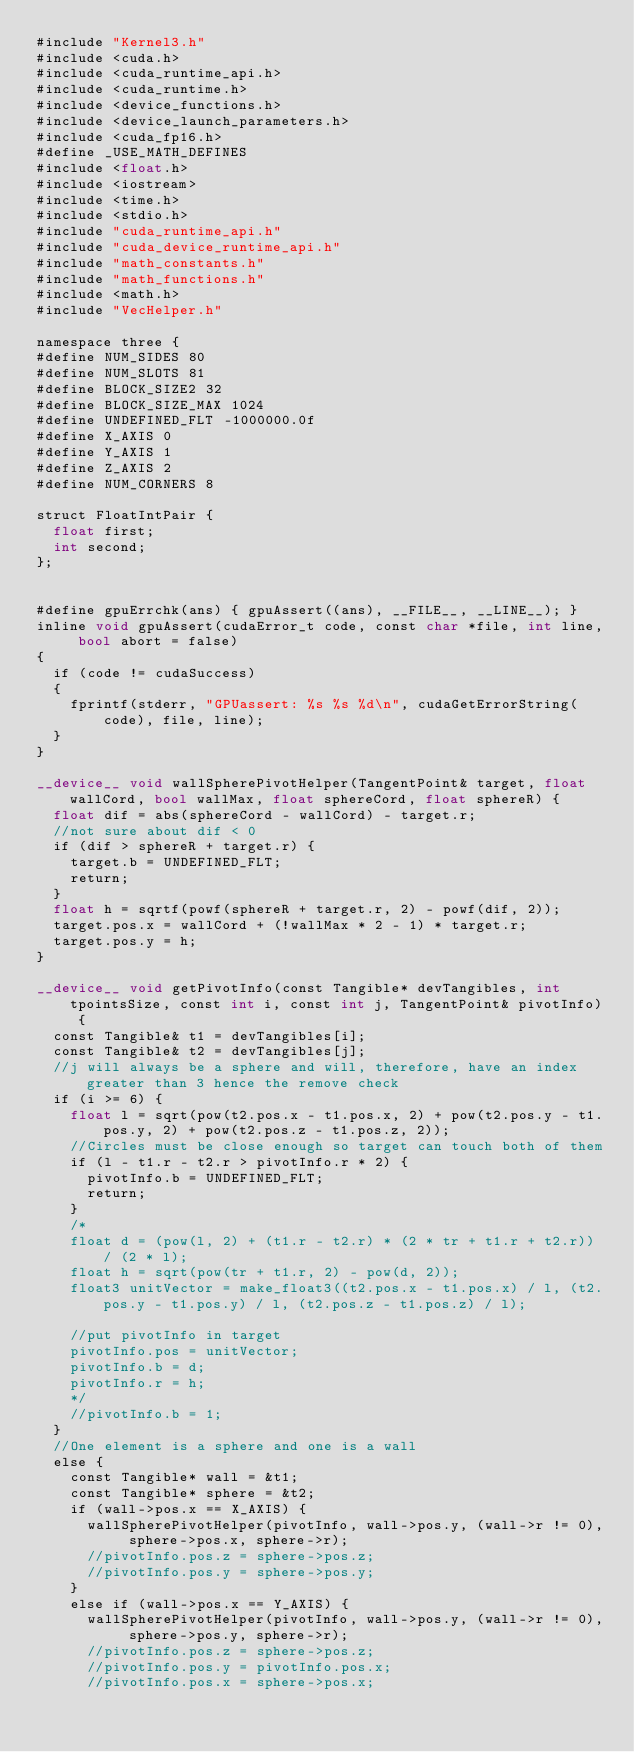<code> <loc_0><loc_0><loc_500><loc_500><_Cuda_>#include "Kernel3.h"
#include <cuda.h>
#include <cuda_runtime_api.h>
#include <cuda_runtime.h>
#include <device_functions.h>
#include <device_launch_parameters.h>
#include <cuda_fp16.h>
#define _USE_MATH_DEFINES
#include <float.h>
#include <iostream>
#include <time.h>
#include <stdio.h>
#include "cuda_runtime_api.h"
#include "cuda_device_runtime_api.h"
#include "math_constants.h"
#include "math_functions.h"
#include <math.h>
#include "VecHelper.h"

namespace three {
#define NUM_SIDES 80
#define NUM_SLOTS 81
#define BLOCK_SIZE2 32
#define BLOCK_SIZE_MAX 1024
#define UNDEFINED_FLT -1000000.0f
#define X_AXIS 0
#define Y_AXIS 1
#define Z_AXIS 2
#define NUM_CORNERS 8

struct FloatIntPair {
	float first;
	int second;
};


#define gpuErrchk(ans) { gpuAssert((ans), __FILE__, __LINE__); }
inline void gpuAssert(cudaError_t code, const char *file, int line, bool abort = false)
{
	if (code != cudaSuccess)
	{
		fprintf(stderr, "GPUassert: %s %s %d\n", cudaGetErrorString(code), file, line);
	}
}

__device__ void wallSpherePivotHelper(TangentPoint& target, float wallCord, bool wallMax, float sphereCord, float sphereR) {
	float dif = abs(sphereCord - wallCord) - target.r;
	//not sure about dif < 0
	if (dif > sphereR + target.r) {
		target.b = UNDEFINED_FLT;
		return;
	}
	float h = sqrtf(powf(sphereR + target.r, 2) - powf(dif, 2));
	target.pos.x = wallCord + (!wallMax * 2 - 1) * target.r;
	target.pos.y = h;
}

__device__ void getPivotInfo(const Tangible* devTangibles, int tpointsSize, const int i, const int j, TangentPoint& pivotInfo) {
	const Tangible& t1 = devTangibles[i];
	const Tangible& t2 = devTangibles[j];
	//j will always be a sphere and will, therefore, have an index greater than 3 hence the remove check
	if (i >= 6) {
		float l = sqrt(pow(t2.pos.x - t1.pos.x, 2) + pow(t2.pos.y - t1.pos.y, 2) + pow(t2.pos.z - t1.pos.z, 2));
		//Circles must be close enough so target can touch both of them
		if (l - t1.r - t2.r > pivotInfo.r * 2) {
			pivotInfo.b = UNDEFINED_FLT;
			return;
		}
		/*
		float d = (pow(l, 2) + (t1.r - t2.r) * (2 * tr + t1.r + t2.r)) / (2 * l);
		float h = sqrt(pow(tr + t1.r, 2) - pow(d, 2));
		float3 unitVector = make_float3((t2.pos.x - t1.pos.x) / l, (t2.pos.y - t1.pos.y) / l, (t2.pos.z - t1.pos.z) / l);

		//put pivotInfo in target
		pivotInfo.pos = unitVector;
		pivotInfo.b = d;
		pivotInfo.r = h;
		*/
		//pivotInfo.b = 1;
	}
	//One element is a sphere and one is a wall
	else {
		const Tangible* wall = &t1;
		const Tangible* sphere = &t2;
		if (wall->pos.x == X_AXIS) {
			wallSpherePivotHelper(pivotInfo, wall->pos.y, (wall->r != 0), sphere->pos.x, sphere->r);
			//pivotInfo.pos.z = sphere->pos.z;
			//pivotInfo.pos.y = sphere->pos.y;
		}
		else if (wall->pos.x == Y_AXIS) {
			wallSpherePivotHelper(pivotInfo, wall->pos.y, (wall->r != 0), sphere->pos.y, sphere->r);
			//pivotInfo.pos.z = sphere->pos.z;
			//pivotInfo.pos.y = pivotInfo.pos.x;
			//pivotInfo.pos.x = sphere->pos.x;</code> 